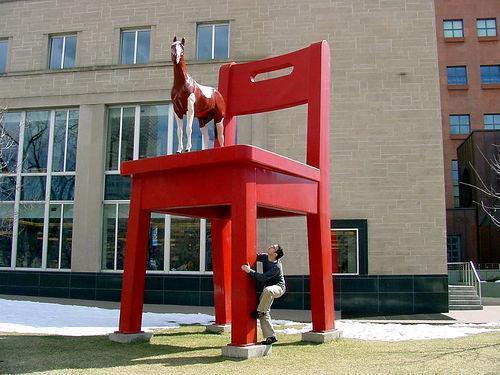How many chairs are in the picture?
Give a very brief answer. 1. 